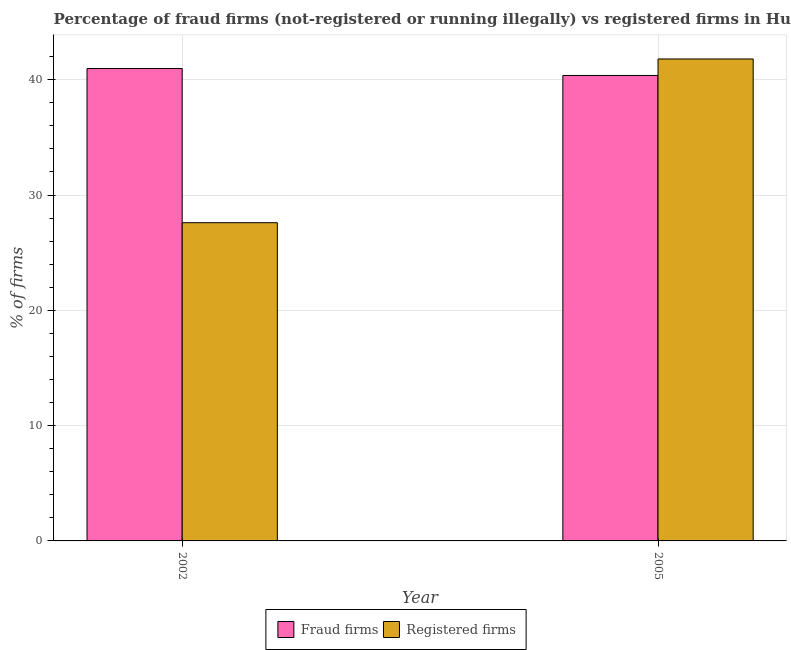How many different coloured bars are there?
Your response must be concise. 2. How many groups of bars are there?
Keep it short and to the point. 2. How many bars are there on the 2nd tick from the right?
Provide a short and direct response. 2. What is the label of the 1st group of bars from the left?
Make the answer very short. 2002. What is the percentage of fraud firms in 2005?
Provide a short and direct response. 40.37. Across all years, what is the maximum percentage of fraud firms?
Ensure brevity in your answer.  40.97. Across all years, what is the minimum percentage of registered firms?
Your answer should be very brief. 27.6. In which year was the percentage of fraud firms maximum?
Offer a very short reply. 2002. In which year was the percentage of registered firms minimum?
Keep it short and to the point. 2002. What is the total percentage of fraud firms in the graph?
Your response must be concise. 81.34. What is the difference between the percentage of fraud firms in 2002 and that in 2005?
Offer a terse response. 0.6. What is the difference between the percentage of fraud firms in 2005 and the percentage of registered firms in 2002?
Offer a very short reply. -0.6. What is the average percentage of registered firms per year?
Your answer should be compact. 34.7. What is the ratio of the percentage of registered firms in 2002 to that in 2005?
Make the answer very short. 0.66. Is the percentage of fraud firms in 2002 less than that in 2005?
Keep it short and to the point. No. In how many years, is the percentage of registered firms greater than the average percentage of registered firms taken over all years?
Offer a terse response. 1. What does the 2nd bar from the left in 2002 represents?
Your response must be concise. Registered firms. What does the 2nd bar from the right in 2002 represents?
Offer a terse response. Fraud firms. Are all the bars in the graph horizontal?
Make the answer very short. No. What is the difference between two consecutive major ticks on the Y-axis?
Offer a terse response. 10. Does the graph contain grids?
Make the answer very short. Yes. How many legend labels are there?
Ensure brevity in your answer.  2. What is the title of the graph?
Provide a succinct answer. Percentage of fraud firms (not-registered or running illegally) vs registered firms in Hungary. What is the label or title of the X-axis?
Ensure brevity in your answer.  Year. What is the label or title of the Y-axis?
Give a very brief answer. % of firms. What is the % of firms of Fraud firms in 2002?
Offer a terse response. 40.97. What is the % of firms in Registered firms in 2002?
Offer a terse response. 27.6. What is the % of firms of Fraud firms in 2005?
Your answer should be compact. 40.37. What is the % of firms of Registered firms in 2005?
Make the answer very short. 41.8. Across all years, what is the maximum % of firms in Fraud firms?
Provide a short and direct response. 40.97. Across all years, what is the maximum % of firms in Registered firms?
Ensure brevity in your answer.  41.8. Across all years, what is the minimum % of firms in Fraud firms?
Make the answer very short. 40.37. Across all years, what is the minimum % of firms in Registered firms?
Make the answer very short. 27.6. What is the total % of firms of Fraud firms in the graph?
Offer a terse response. 81.34. What is the total % of firms of Registered firms in the graph?
Your answer should be compact. 69.4. What is the difference between the % of firms of Fraud firms in 2002 and the % of firms of Registered firms in 2005?
Make the answer very short. -0.83. What is the average % of firms in Fraud firms per year?
Provide a short and direct response. 40.67. What is the average % of firms of Registered firms per year?
Ensure brevity in your answer.  34.7. In the year 2002, what is the difference between the % of firms in Fraud firms and % of firms in Registered firms?
Your answer should be very brief. 13.37. In the year 2005, what is the difference between the % of firms in Fraud firms and % of firms in Registered firms?
Ensure brevity in your answer.  -1.43. What is the ratio of the % of firms of Fraud firms in 2002 to that in 2005?
Offer a very short reply. 1.01. What is the ratio of the % of firms in Registered firms in 2002 to that in 2005?
Offer a terse response. 0.66. What is the difference between the highest and the second highest % of firms of Fraud firms?
Provide a succinct answer. 0.6. What is the difference between the highest and the lowest % of firms in Fraud firms?
Offer a terse response. 0.6. 